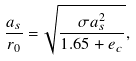<formula> <loc_0><loc_0><loc_500><loc_500>\frac { a _ { s } } { r _ { 0 } } = \sqrt { \frac { \sigma a _ { s } ^ { 2 } } { 1 . 6 5 + e _ { c } } } ,</formula> 